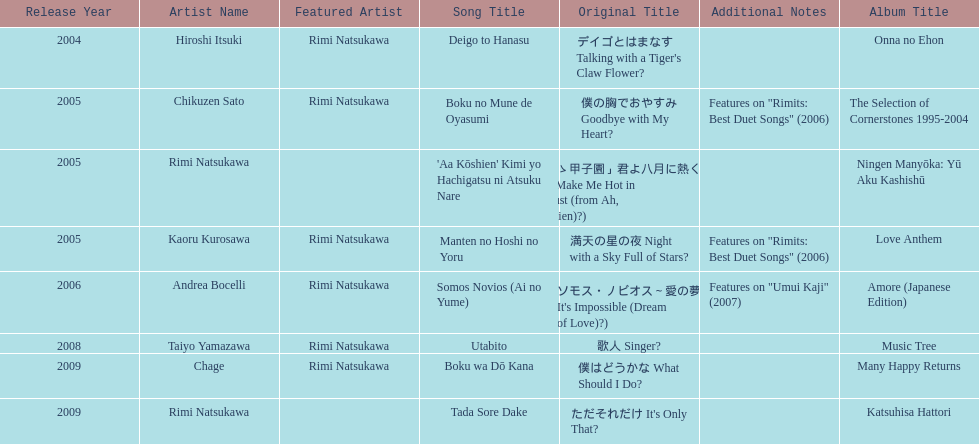How many other appearance did this artist make in 2005? 3. 